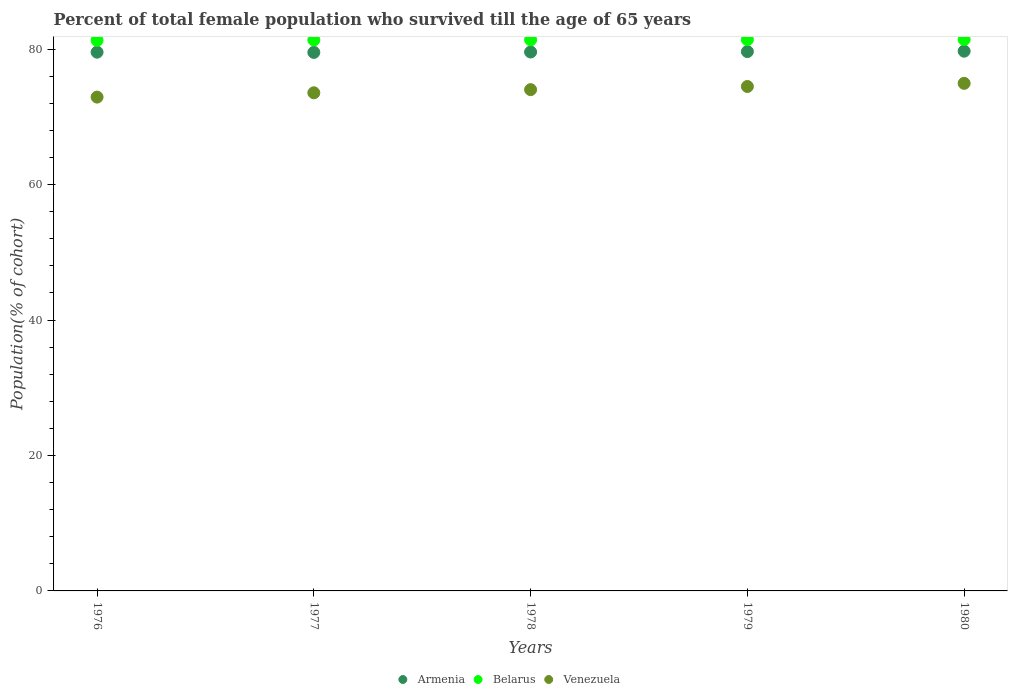Is the number of dotlines equal to the number of legend labels?
Make the answer very short. Yes. What is the percentage of total female population who survived till the age of 65 years in Venezuela in 1976?
Your answer should be very brief. 72.93. Across all years, what is the maximum percentage of total female population who survived till the age of 65 years in Belarus?
Make the answer very short. 81.44. Across all years, what is the minimum percentage of total female population who survived till the age of 65 years in Armenia?
Your answer should be compact. 79.53. In which year was the percentage of total female population who survived till the age of 65 years in Belarus maximum?
Provide a succinct answer. 1980. In which year was the percentage of total female population who survived till the age of 65 years in Armenia minimum?
Make the answer very short. 1977. What is the total percentage of total female population who survived till the age of 65 years in Armenia in the graph?
Your answer should be very brief. 398.04. What is the difference between the percentage of total female population who survived till the age of 65 years in Venezuela in 1976 and that in 1980?
Offer a terse response. -2.03. What is the difference between the percentage of total female population who survived till the age of 65 years in Belarus in 1980 and the percentage of total female population who survived till the age of 65 years in Venezuela in 1977?
Provide a succinct answer. 7.88. What is the average percentage of total female population who survived till the age of 65 years in Venezuela per year?
Ensure brevity in your answer.  74. In the year 1976, what is the difference between the percentage of total female population who survived till the age of 65 years in Armenia and percentage of total female population who survived till the age of 65 years in Belarus?
Make the answer very short. -1.75. In how many years, is the percentage of total female population who survived till the age of 65 years in Armenia greater than 36 %?
Offer a very short reply. 5. What is the ratio of the percentage of total female population who survived till the age of 65 years in Belarus in 1977 to that in 1979?
Ensure brevity in your answer.  1. Is the difference between the percentage of total female population who survived till the age of 65 years in Armenia in 1978 and 1979 greater than the difference between the percentage of total female population who survived till the age of 65 years in Belarus in 1978 and 1979?
Keep it short and to the point. No. What is the difference between the highest and the second highest percentage of total female population who survived till the age of 65 years in Venezuela?
Offer a very short reply. 0.47. What is the difference between the highest and the lowest percentage of total female population who survived till the age of 65 years in Armenia?
Your response must be concise. 0.18. In how many years, is the percentage of total female population who survived till the age of 65 years in Venezuela greater than the average percentage of total female population who survived till the age of 65 years in Venezuela taken over all years?
Make the answer very short. 3. Does the percentage of total female population who survived till the age of 65 years in Armenia monotonically increase over the years?
Ensure brevity in your answer.  No. Where does the legend appear in the graph?
Provide a short and direct response. Bottom center. How many legend labels are there?
Offer a terse response. 3. How are the legend labels stacked?
Offer a terse response. Horizontal. What is the title of the graph?
Ensure brevity in your answer.  Percent of total female population who survived till the age of 65 years. What is the label or title of the X-axis?
Provide a succinct answer. Years. What is the label or title of the Y-axis?
Keep it short and to the point. Population(% of cohort). What is the Population(% of cohort) of Armenia in 1976?
Provide a succinct answer. 79.56. What is the Population(% of cohort) of Belarus in 1976?
Offer a very short reply. 81.31. What is the Population(% of cohort) of Venezuela in 1976?
Keep it short and to the point. 72.93. What is the Population(% of cohort) of Armenia in 1977?
Provide a succinct answer. 79.53. What is the Population(% of cohort) of Belarus in 1977?
Ensure brevity in your answer.  81.37. What is the Population(% of cohort) of Venezuela in 1977?
Give a very brief answer. 73.56. What is the Population(% of cohort) in Armenia in 1978?
Ensure brevity in your answer.  79.59. What is the Population(% of cohort) of Belarus in 1978?
Your answer should be compact. 81.39. What is the Population(% of cohort) of Venezuela in 1978?
Your answer should be very brief. 74.03. What is the Population(% of cohort) of Armenia in 1979?
Make the answer very short. 79.65. What is the Population(% of cohort) of Belarus in 1979?
Offer a very short reply. 81.42. What is the Population(% of cohort) in Venezuela in 1979?
Ensure brevity in your answer.  74.49. What is the Population(% of cohort) in Armenia in 1980?
Give a very brief answer. 79.71. What is the Population(% of cohort) in Belarus in 1980?
Offer a terse response. 81.44. What is the Population(% of cohort) of Venezuela in 1980?
Make the answer very short. 74.96. Across all years, what is the maximum Population(% of cohort) of Armenia?
Keep it short and to the point. 79.71. Across all years, what is the maximum Population(% of cohort) in Belarus?
Offer a very short reply. 81.44. Across all years, what is the maximum Population(% of cohort) of Venezuela?
Your answer should be compact. 74.96. Across all years, what is the minimum Population(% of cohort) of Armenia?
Provide a short and direct response. 79.53. Across all years, what is the minimum Population(% of cohort) of Belarus?
Your answer should be compact. 81.31. Across all years, what is the minimum Population(% of cohort) in Venezuela?
Your answer should be very brief. 72.93. What is the total Population(% of cohort) of Armenia in the graph?
Your answer should be very brief. 398.04. What is the total Population(% of cohort) in Belarus in the graph?
Offer a terse response. 406.93. What is the total Population(% of cohort) in Venezuela in the graph?
Your answer should be compact. 369.98. What is the difference between the Population(% of cohort) of Armenia in 1976 and that in 1977?
Provide a succinct answer. 0.03. What is the difference between the Population(% of cohort) of Belarus in 1976 and that in 1977?
Keep it short and to the point. -0.06. What is the difference between the Population(% of cohort) in Venezuela in 1976 and that in 1977?
Provide a short and direct response. -0.64. What is the difference between the Population(% of cohort) in Armenia in 1976 and that in 1978?
Give a very brief answer. -0.03. What is the difference between the Population(% of cohort) of Belarus in 1976 and that in 1978?
Make the answer very short. -0.08. What is the difference between the Population(% of cohort) in Venezuela in 1976 and that in 1978?
Your answer should be compact. -1.1. What is the difference between the Population(% of cohort) in Armenia in 1976 and that in 1979?
Your answer should be compact. -0.09. What is the difference between the Population(% of cohort) in Belarus in 1976 and that in 1979?
Provide a succinct answer. -0.11. What is the difference between the Population(% of cohort) of Venezuela in 1976 and that in 1979?
Provide a succinct answer. -1.57. What is the difference between the Population(% of cohort) of Armenia in 1976 and that in 1980?
Your answer should be compact. -0.15. What is the difference between the Population(% of cohort) in Belarus in 1976 and that in 1980?
Make the answer very short. -0.13. What is the difference between the Population(% of cohort) of Venezuela in 1976 and that in 1980?
Your response must be concise. -2.03. What is the difference between the Population(% of cohort) in Armenia in 1977 and that in 1978?
Provide a short and direct response. -0.06. What is the difference between the Population(% of cohort) in Belarus in 1977 and that in 1978?
Make the answer very short. -0.02. What is the difference between the Population(% of cohort) of Venezuela in 1977 and that in 1978?
Ensure brevity in your answer.  -0.47. What is the difference between the Population(% of cohort) in Armenia in 1977 and that in 1979?
Provide a short and direct response. -0.12. What is the difference between the Population(% of cohort) in Belarus in 1977 and that in 1979?
Your answer should be very brief. -0.05. What is the difference between the Population(% of cohort) of Venezuela in 1977 and that in 1979?
Offer a very short reply. -0.93. What is the difference between the Population(% of cohort) of Armenia in 1977 and that in 1980?
Provide a short and direct response. -0.18. What is the difference between the Population(% of cohort) of Belarus in 1977 and that in 1980?
Offer a very short reply. -0.07. What is the difference between the Population(% of cohort) of Venezuela in 1977 and that in 1980?
Give a very brief answer. -1.4. What is the difference between the Population(% of cohort) of Armenia in 1978 and that in 1979?
Provide a short and direct response. -0.06. What is the difference between the Population(% of cohort) of Belarus in 1978 and that in 1979?
Your answer should be compact. -0.02. What is the difference between the Population(% of cohort) of Venezuela in 1978 and that in 1979?
Offer a very short reply. -0.47. What is the difference between the Population(% of cohort) of Armenia in 1978 and that in 1980?
Provide a short and direct response. -0.12. What is the difference between the Population(% of cohort) in Belarus in 1978 and that in 1980?
Your answer should be compact. -0.05. What is the difference between the Population(% of cohort) of Venezuela in 1978 and that in 1980?
Your answer should be compact. -0.93. What is the difference between the Population(% of cohort) of Armenia in 1979 and that in 1980?
Give a very brief answer. -0.06. What is the difference between the Population(% of cohort) of Belarus in 1979 and that in 1980?
Provide a short and direct response. -0.02. What is the difference between the Population(% of cohort) in Venezuela in 1979 and that in 1980?
Give a very brief answer. -0.47. What is the difference between the Population(% of cohort) of Armenia in 1976 and the Population(% of cohort) of Belarus in 1977?
Your response must be concise. -1.81. What is the difference between the Population(% of cohort) of Armenia in 1976 and the Population(% of cohort) of Venezuela in 1977?
Provide a succinct answer. 6. What is the difference between the Population(% of cohort) in Belarus in 1976 and the Population(% of cohort) in Venezuela in 1977?
Provide a short and direct response. 7.75. What is the difference between the Population(% of cohort) in Armenia in 1976 and the Population(% of cohort) in Belarus in 1978?
Your response must be concise. -1.83. What is the difference between the Population(% of cohort) in Armenia in 1976 and the Population(% of cohort) in Venezuela in 1978?
Your answer should be very brief. 5.53. What is the difference between the Population(% of cohort) of Belarus in 1976 and the Population(% of cohort) of Venezuela in 1978?
Your answer should be very brief. 7.28. What is the difference between the Population(% of cohort) in Armenia in 1976 and the Population(% of cohort) in Belarus in 1979?
Keep it short and to the point. -1.85. What is the difference between the Population(% of cohort) in Armenia in 1976 and the Population(% of cohort) in Venezuela in 1979?
Keep it short and to the point. 5.07. What is the difference between the Population(% of cohort) in Belarus in 1976 and the Population(% of cohort) in Venezuela in 1979?
Keep it short and to the point. 6.82. What is the difference between the Population(% of cohort) in Armenia in 1976 and the Population(% of cohort) in Belarus in 1980?
Your response must be concise. -1.88. What is the difference between the Population(% of cohort) of Armenia in 1976 and the Population(% of cohort) of Venezuela in 1980?
Provide a succinct answer. 4.6. What is the difference between the Population(% of cohort) in Belarus in 1976 and the Population(% of cohort) in Venezuela in 1980?
Your answer should be compact. 6.35. What is the difference between the Population(% of cohort) of Armenia in 1977 and the Population(% of cohort) of Belarus in 1978?
Provide a short and direct response. -1.86. What is the difference between the Population(% of cohort) of Armenia in 1977 and the Population(% of cohort) of Venezuela in 1978?
Provide a short and direct response. 5.5. What is the difference between the Population(% of cohort) of Belarus in 1977 and the Population(% of cohort) of Venezuela in 1978?
Provide a short and direct response. 7.34. What is the difference between the Population(% of cohort) in Armenia in 1977 and the Population(% of cohort) in Belarus in 1979?
Your answer should be compact. -1.89. What is the difference between the Population(% of cohort) of Armenia in 1977 and the Population(% of cohort) of Venezuela in 1979?
Ensure brevity in your answer.  5.03. What is the difference between the Population(% of cohort) of Belarus in 1977 and the Population(% of cohort) of Venezuela in 1979?
Give a very brief answer. 6.87. What is the difference between the Population(% of cohort) of Armenia in 1977 and the Population(% of cohort) of Belarus in 1980?
Offer a terse response. -1.91. What is the difference between the Population(% of cohort) in Armenia in 1977 and the Population(% of cohort) in Venezuela in 1980?
Provide a succinct answer. 4.57. What is the difference between the Population(% of cohort) in Belarus in 1977 and the Population(% of cohort) in Venezuela in 1980?
Offer a very short reply. 6.41. What is the difference between the Population(% of cohort) in Armenia in 1978 and the Population(% of cohort) in Belarus in 1979?
Provide a succinct answer. -1.83. What is the difference between the Population(% of cohort) of Armenia in 1978 and the Population(% of cohort) of Venezuela in 1979?
Offer a terse response. 5.09. What is the difference between the Population(% of cohort) in Belarus in 1978 and the Population(% of cohort) in Venezuela in 1979?
Provide a short and direct response. 6.9. What is the difference between the Population(% of cohort) of Armenia in 1978 and the Population(% of cohort) of Belarus in 1980?
Your response must be concise. -1.85. What is the difference between the Population(% of cohort) of Armenia in 1978 and the Population(% of cohort) of Venezuela in 1980?
Offer a very short reply. 4.63. What is the difference between the Population(% of cohort) of Belarus in 1978 and the Population(% of cohort) of Venezuela in 1980?
Offer a terse response. 6.43. What is the difference between the Population(% of cohort) in Armenia in 1979 and the Population(% of cohort) in Belarus in 1980?
Keep it short and to the point. -1.79. What is the difference between the Population(% of cohort) of Armenia in 1979 and the Population(% of cohort) of Venezuela in 1980?
Make the answer very short. 4.69. What is the difference between the Population(% of cohort) in Belarus in 1979 and the Population(% of cohort) in Venezuela in 1980?
Offer a very short reply. 6.46. What is the average Population(% of cohort) in Armenia per year?
Your answer should be compact. 79.61. What is the average Population(% of cohort) in Belarus per year?
Provide a short and direct response. 81.39. What is the average Population(% of cohort) in Venezuela per year?
Offer a very short reply. 74. In the year 1976, what is the difference between the Population(% of cohort) in Armenia and Population(% of cohort) in Belarus?
Your answer should be very brief. -1.75. In the year 1976, what is the difference between the Population(% of cohort) of Armenia and Population(% of cohort) of Venezuela?
Your answer should be very brief. 6.64. In the year 1976, what is the difference between the Population(% of cohort) of Belarus and Population(% of cohort) of Venezuela?
Your answer should be very brief. 8.38. In the year 1977, what is the difference between the Population(% of cohort) in Armenia and Population(% of cohort) in Belarus?
Provide a short and direct response. -1.84. In the year 1977, what is the difference between the Population(% of cohort) in Armenia and Population(% of cohort) in Venezuela?
Your answer should be compact. 5.96. In the year 1977, what is the difference between the Population(% of cohort) in Belarus and Population(% of cohort) in Venezuela?
Your response must be concise. 7.8. In the year 1978, what is the difference between the Population(% of cohort) of Armenia and Population(% of cohort) of Belarus?
Offer a terse response. -1.8. In the year 1978, what is the difference between the Population(% of cohort) of Armenia and Population(% of cohort) of Venezuela?
Provide a short and direct response. 5.56. In the year 1978, what is the difference between the Population(% of cohort) in Belarus and Population(% of cohort) in Venezuela?
Provide a short and direct response. 7.36. In the year 1979, what is the difference between the Population(% of cohort) in Armenia and Population(% of cohort) in Belarus?
Your answer should be compact. -1.77. In the year 1979, what is the difference between the Population(% of cohort) of Armenia and Population(% of cohort) of Venezuela?
Your answer should be very brief. 5.16. In the year 1979, what is the difference between the Population(% of cohort) of Belarus and Population(% of cohort) of Venezuela?
Provide a succinct answer. 6.92. In the year 1980, what is the difference between the Population(% of cohort) of Armenia and Population(% of cohort) of Belarus?
Keep it short and to the point. -1.73. In the year 1980, what is the difference between the Population(% of cohort) of Armenia and Population(% of cohort) of Venezuela?
Provide a short and direct response. 4.75. In the year 1980, what is the difference between the Population(% of cohort) of Belarus and Population(% of cohort) of Venezuela?
Your answer should be compact. 6.48. What is the ratio of the Population(% of cohort) of Venezuela in 1976 to that in 1978?
Your answer should be compact. 0.99. What is the ratio of the Population(% of cohort) of Belarus in 1976 to that in 1979?
Your answer should be very brief. 1. What is the ratio of the Population(% of cohort) in Armenia in 1976 to that in 1980?
Offer a terse response. 1. What is the ratio of the Population(% of cohort) of Belarus in 1976 to that in 1980?
Keep it short and to the point. 1. What is the ratio of the Population(% of cohort) of Venezuela in 1976 to that in 1980?
Your response must be concise. 0.97. What is the ratio of the Population(% of cohort) of Belarus in 1977 to that in 1978?
Offer a very short reply. 1. What is the ratio of the Population(% of cohort) in Armenia in 1977 to that in 1979?
Your answer should be compact. 1. What is the ratio of the Population(% of cohort) in Venezuela in 1977 to that in 1979?
Provide a succinct answer. 0.99. What is the ratio of the Population(% of cohort) of Armenia in 1977 to that in 1980?
Ensure brevity in your answer.  1. What is the ratio of the Population(% of cohort) in Venezuela in 1977 to that in 1980?
Your answer should be very brief. 0.98. What is the ratio of the Population(% of cohort) of Belarus in 1978 to that in 1979?
Your answer should be compact. 1. What is the ratio of the Population(% of cohort) in Belarus in 1978 to that in 1980?
Your answer should be compact. 1. What is the ratio of the Population(% of cohort) of Venezuela in 1978 to that in 1980?
Your answer should be very brief. 0.99. What is the ratio of the Population(% of cohort) in Armenia in 1979 to that in 1980?
Make the answer very short. 1. What is the ratio of the Population(% of cohort) in Belarus in 1979 to that in 1980?
Your response must be concise. 1. What is the difference between the highest and the second highest Population(% of cohort) in Armenia?
Your answer should be very brief. 0.06. What is the difference between the highest and the second highest Population(% of cohort) in Belarus?
Provide a succinct answer. 0.02. What is the difference between the highest and the second highest Population(% of cohort) in Venezuela?
Offer a very short reply. 0.47. What is the difference between the highest and the lowest Population(% of cohort) in Armenia?
Offer a terse response. 0.18. What is the difference between the highest and the lowest Population(% of cohort) of Belarus?
Offer a very short reply. 0.13. What is the difference between the highest and the lowest Population(% of cohort) in Venezuela?
Offer a very short reply. 2.03. 